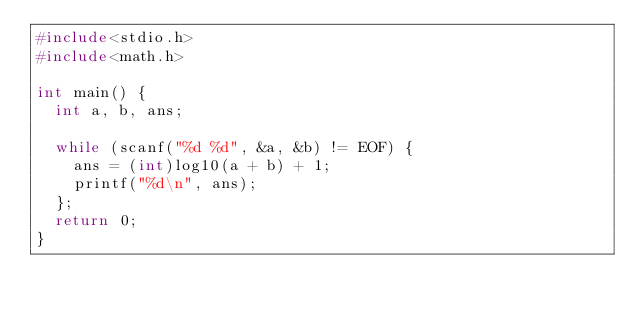Convert code to text. <code><loc_0><loc_0><loc_500><loc_500><_C_>#include<stdio.h>
#include<math.h>
   
int main() {
  int a, b, ans;
     
  while (scanf("%d %d", &a, &b) != EOF) {
    ans = (int)log10(a + b) + 1;
    printf("%d\n", ans);
  };
  return 0;
}</code> 